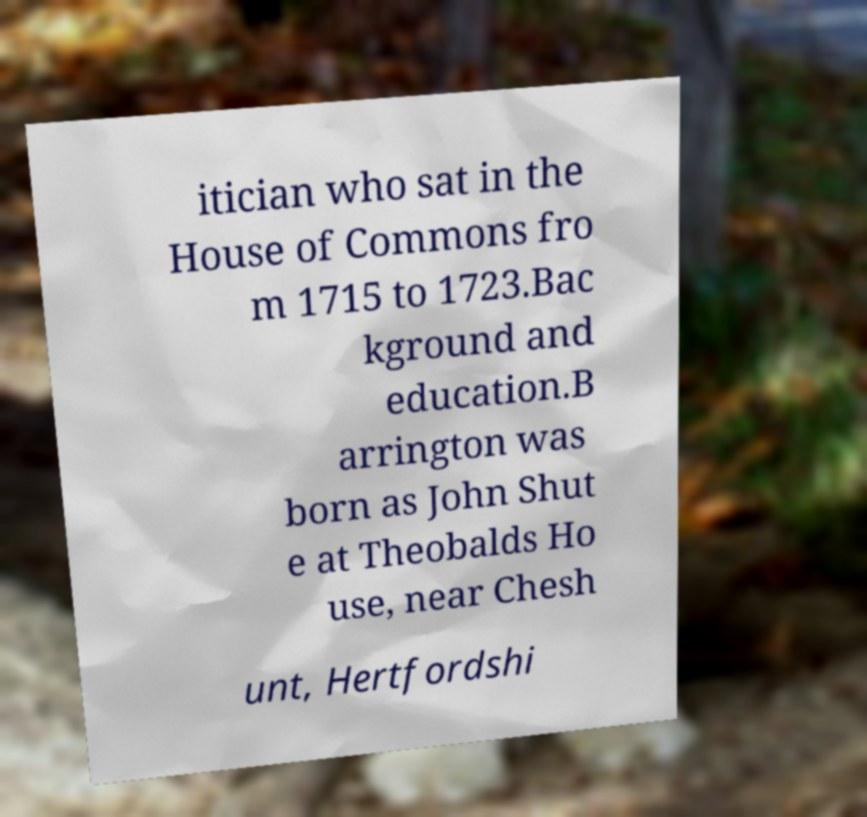Can you read and provide the text displayed in the image?This photo seems to have some interesting text. Can you extract and type it out for me? itician who sat in the House of Commons fro m 1715 to 1723.Bac kground and education.B arrington was born as John Shut e at Theobalds Ho use, near Chesh unt, Hertfordshi 